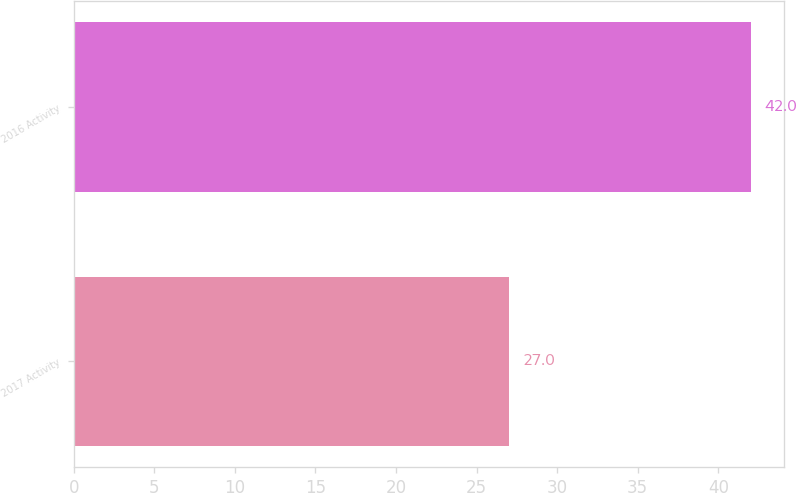Convert chart to OTSL. <chart><loc_0><loc_0><loc_500><loc_500><bar_chart><fcel>2017 Activity<fcel>2016 Activity<nl><fcel>27<fcel>42<nl></chart> 